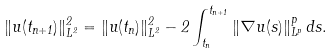Convert formula to latex. <formula><loc_0><loc_0><loc_500><loc_500>\| u ( t _ { n + 1 } ) \| _ { L ^ { 2 } } ^ { 2 } = \| u ( t _ { n } ) \| _ { L ^ { 2 } } ^ { 2 } - 2 \int _ { t _ { n } } ^ { t _ { n + 1 } } \| \nabla u ( s ) \| _ { L ^ { p } } ^ { p } \, d s .</formula> 